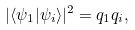<formula> <loc_0><loc_0><loc_500><loc_500>| \langle \psi _ { 1 } | \psi _ { i } \rangle | ^ { 2 } = q _ { 1 } q _ { i } ,</formula> 